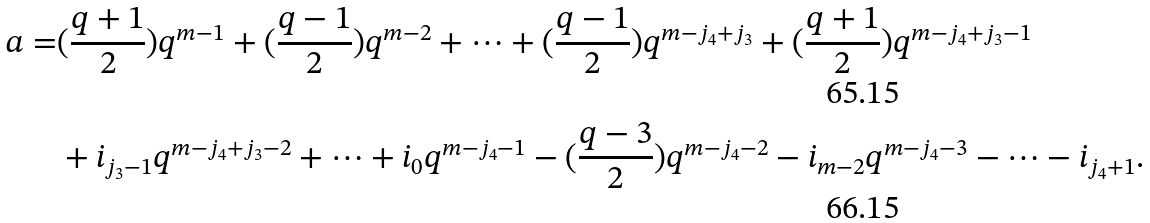Convert formula to latex. <formula><loc_0><loc_0><loc_500><loc_500>a = & ( \frac { q + 1 } 2 ) q ^ { m - 1 } + ( \frac { q - 1 } 2 ) q ^ { m - 2 } + \cdots + ( \frac { q - 1 } 2 ) q ^ { m - j _ { 4 } + j _ { 3 } } + ( \frac { q + 1 } 2 ) q ^ { m - j _ { 4 } + j _ { 3 } - 1 } \\ & + i _ { j _ { 3 } - 1 } q ^ { m - j _ { 4 } + j _ { 3 } - 2 } + \cdots + i _ { 0 } q ^ { m - j _ { 4 } - 1 } - ( \frac { q - 3 } 2 ) q ^ { m - j _ { 4 } - 2 } - i _ { m - 2 } q ^ { m - j _ { 4 } - 3 } - \cdots - i _ { j _ { 4 } + 1 } .</formula> 